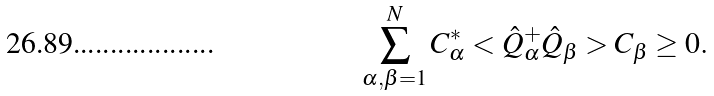<formula> <loc_0><loc_0><loc_500><loc_500>\sum _ { \alpha , \beta = 1 } ^ { N } C _ { \alpha } ^ { * } < \hat { Q } ^ { + } _ { \alpha } \hat { Q } _ { \beta } > C _ { \beta } \geq 0 .</formula> 